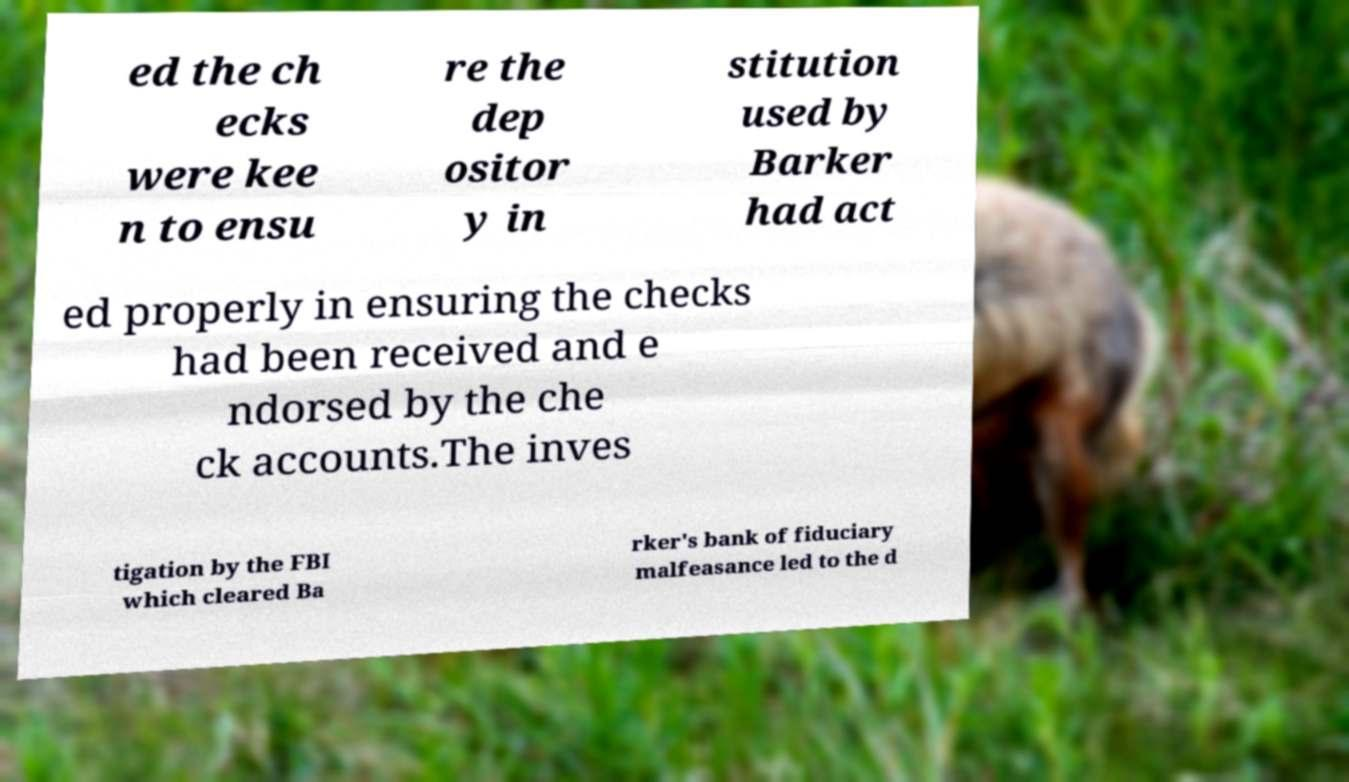Could you extract and type out the text from this image? ed the ch ecks were kee n to ensu re the dep ositor y in stitution used by Barker had act ed properly in ensuring the checks had been received and e ndorsed by the che ck accounts.The inves tigation by the FBI which cleared Ba rker's bank of fiduciary malfeasance led to the d 